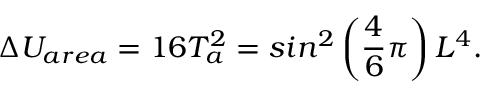<formula> <loc_0><loc_0><loc_500><loc_500>\Delta U _ { a r e a } = 1 6 T _ { a } ^ { 2 } = \sin ^ { 2 } \left ( \frac { 4 } { 6 } \pi \right ) L ^ { 4 } .</formula> 